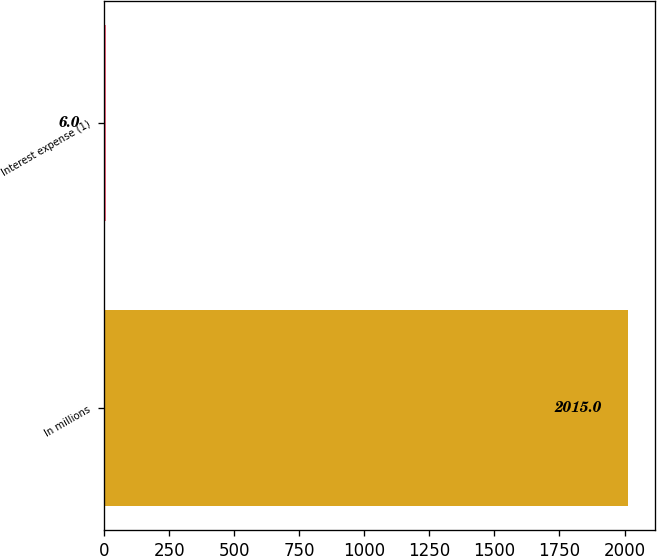Convert chart to OTSL. <chart><loc_0><loc_0><loc_500><loc_500><bar_chart><fcel>In millions<fcel>Interest expense (1)<nl><fcel>2015<fcel>6<nl></chart> 